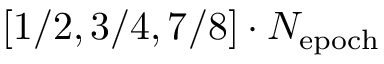Convert formula to latex. <formula><loc_0><loc_0><loc_500><loc_500>[ 1 / 2 , 3 / 4 , 7 / 8 ] \cdot N _ { e p o c h }</formula> 